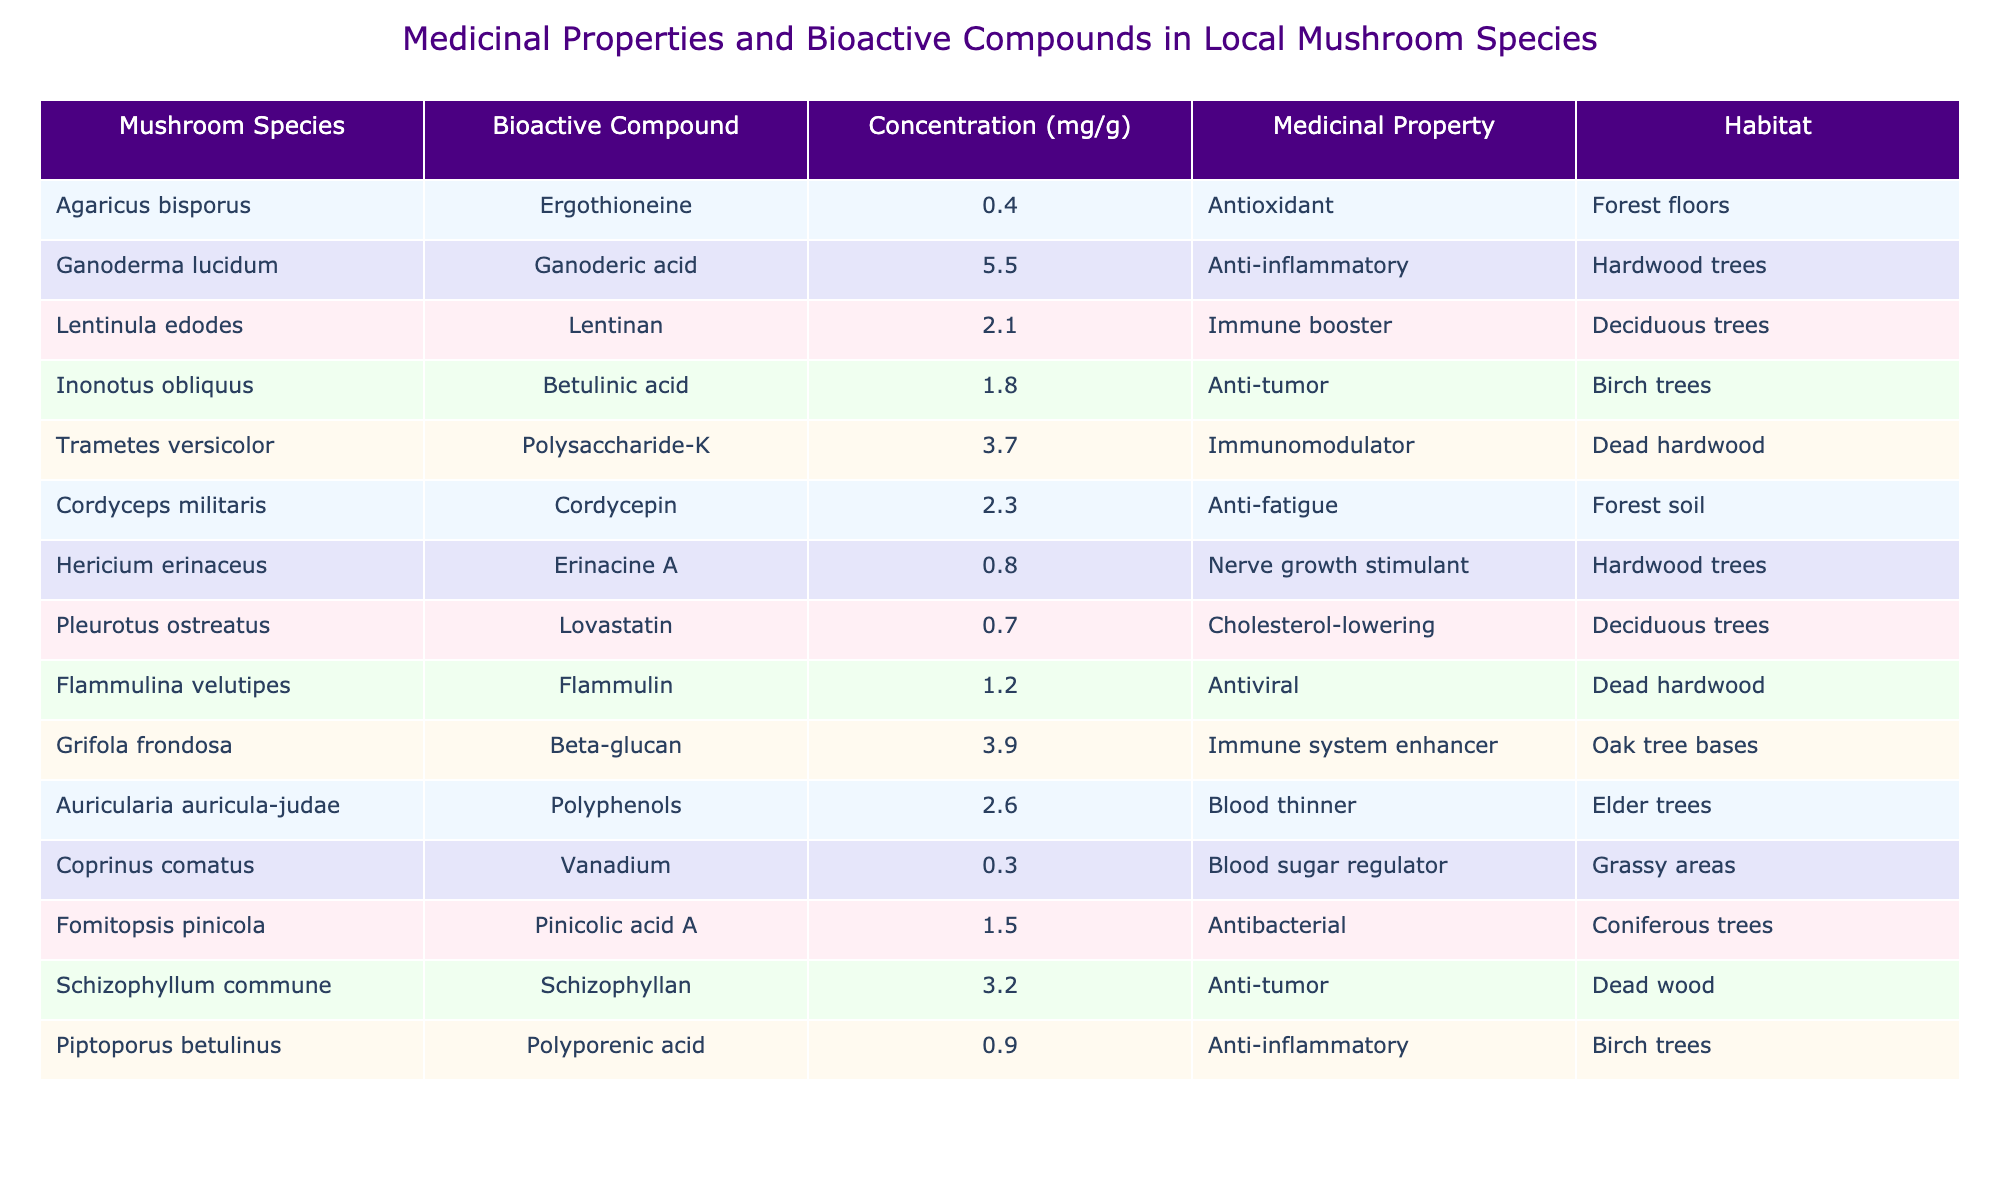What bioactive compound does Ganoderma lucidum contain? The table states that Ganoderma lucidum contains Ganoderic acid.
Answer: Ganoderic acid Which mushroom species has the highest concentration of bioactive compounds? By examining the concentration values in the table, Ganoderma lucidum has the highest concentration at 5.5 mg/g.
Answer: Ganoderma lucidum How many mushroom species in the table have anti-inflammatory properties? There are two species listed with anti-inflammatory properties: Ganoderma lucidum and Piptoporus betulinus.
Answer: Two What is the average concentration of bioactive compounds among all mushroom species listed? To find the average, sum all the concentrations (0.4 + 5.5 + 2.1 + 1.8 + 3.7 + 2.3 + 0.8 + 0.7 + 1.2 + 3.9 + 2.6 + 0.3 + 1.5 + 3.2 + 0.9 = 24.4) and then divide by the number of species (15). Therefore, the average concentration is 24.4 / 15 = 1.6267 mg/g.
Answer: 1.63 mg/g Which mushroom has the lowest concentration of a bioactive compound and what is that concentration? Looking at the table, Coprinus comatus has the lowest concentration of 0.3 mg/g.
Answer: 0.3 mg/g Is Flammulina velutipes associated with any immune-boosting properties? Flammulina velutipes is not listed as having immune-boosting properties; it is noted for its antiviral property instead.
Answer: No What are the medicinal properties associated with mushrooms found in the habitat of hardwood trees? From the table, the medicinal properties associated with mushrooms found in hardwood trees include anti-inflammatory (Ganoderma lucidum), nerve growth stimulant (Hericium erinaceus), and immune booster (Lentinula edodes).
Answer: Anti-inflammatory, nerve growth stimulant, immune booster Which habitat has the most medicinal properties listed in the table? By reviewing the habitats, both hardwood trees and deciduous trees have multiple medicinal properties associated with them. However, hardwood trees have three properties listed while deciduous trees have two. Thus, hardwood trees are more predominant in medicinal properties.
Answer: Hardwood trees How many different types of medicinal properties are mentioned in total? The table lists the following unique medicinal properties: antioxidant, anti-inflammatory, immune booster, anti-tumor, immunomodulator, anti-fatigue, nerve growth stimulant, cholesterol-lowering, antiviral, immune system enhancer, blood thinner, blood sugar regulator, antibacterial. That totals to 13 unique medicinal properties.
Answer: 13 What concentration do the blood thinner associated mushrooms have, and which species are they? Auricularia auricula-judae is the species associated with blood thinner properties, and it has a concentration of 2.6 mg/g.
Answer: 2.6 mg/g, Auricularia auricula-judae If you wanted to maximize pain relief using mushrooms from the table, which species would you choose? To maximize pain relief, Ganoderma lucidum should be chosen as it is anti-inflammatory and has a high concentration of 5.5 mg/g.
Answer: Ganoderma lucidum 